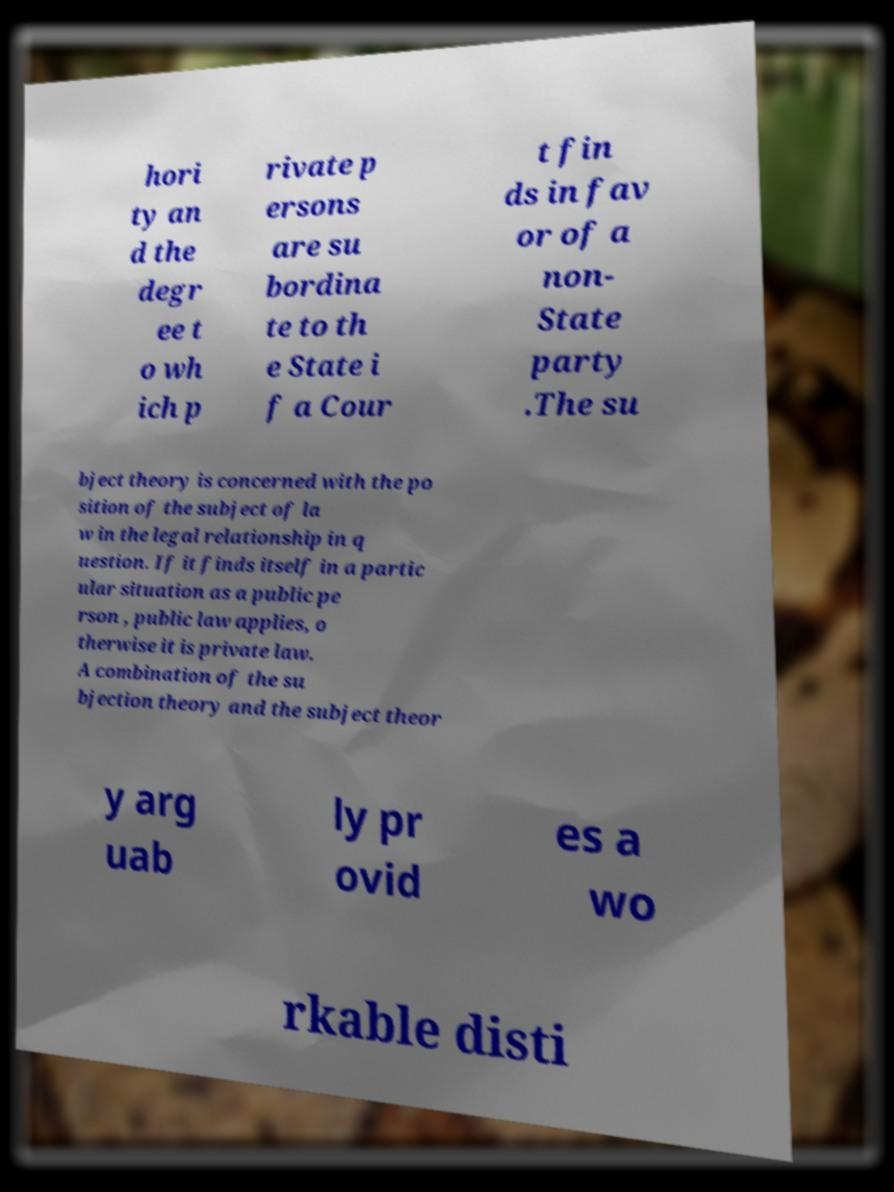I need the written content from this picture converted into text. Can you do that? hori ty an d the degr ee t o wh ich p rivate p ersons are su bordina te to th e State i f a Cour t fin ds in fav or of a non- State party .The su bject theory is concerned with the po sition of the subject of la w in the legal relationship in q uestion. If it finds itself in a partic ular situation as a public pe rson , public law applies, o therwise it is private law. A combination of the su bjection theory and the subject theor y arg uab ly pr ovid es a wo rkable disti 